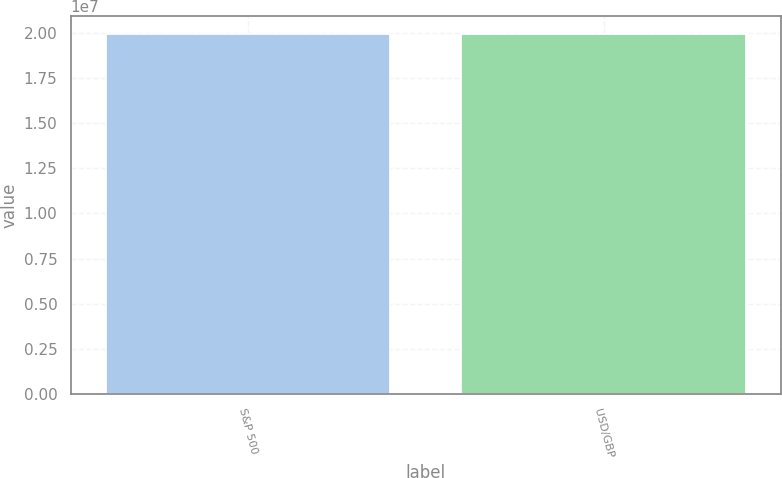<chart> <loc_0><loc_0><loc_500><loc_500><bar_chart><fcel>S&P 500<fcel>USD/GBP<nl><fcel>1.9952e+07<fcel>1.9952e+07<nl></chart> 